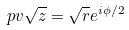<formula> <loc_0><loc_0><loc_500><loc_500>p v \sqrt { z } = \sqrt { r } e ^ { i \phi / 2 }</formula> 